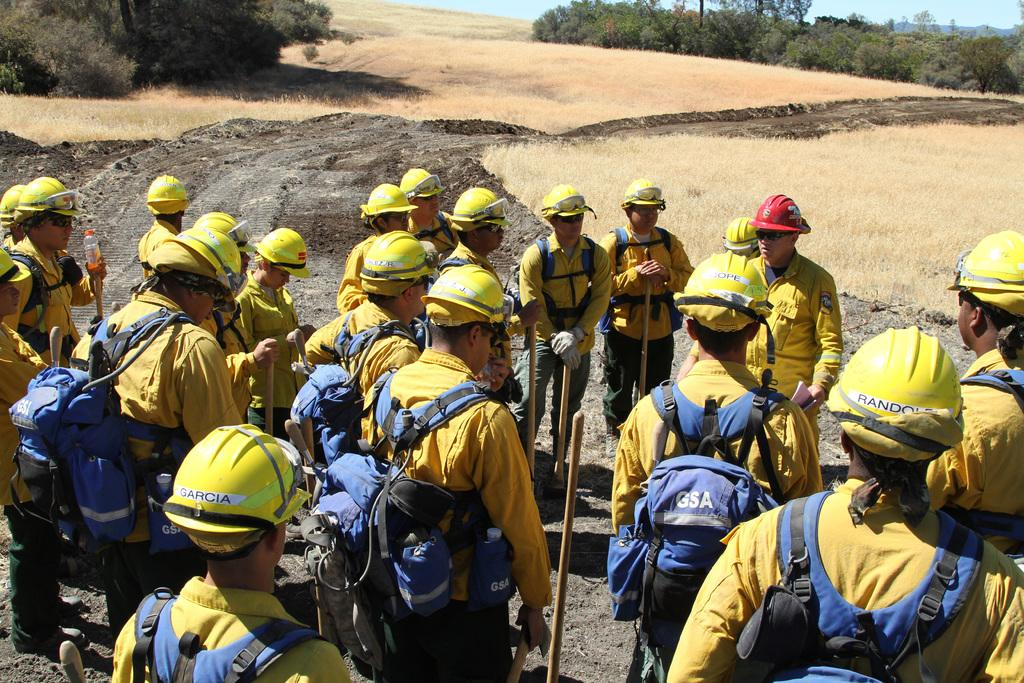How many persons are in the image? There are persons in the image. What are the persons wearing on their heads? The persons are wearing helmets. What are the persons wearing on their bodies? The persons are wearing bags. What type of ground is visible in the image? There is grass on the ground in the image. Where are plants located in the image? There are plants in the top left and top right of the image. What type of tramp can be seen in the image? There is no tramp present in the image. What level of difficulty is the border in the image? There is no border present in the image, so it is not possible to determine its level of difficulty. 